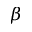Convert formula to latex. <formula><loc_0><loc_0><loc_500><loc_500>\beta</formula> 